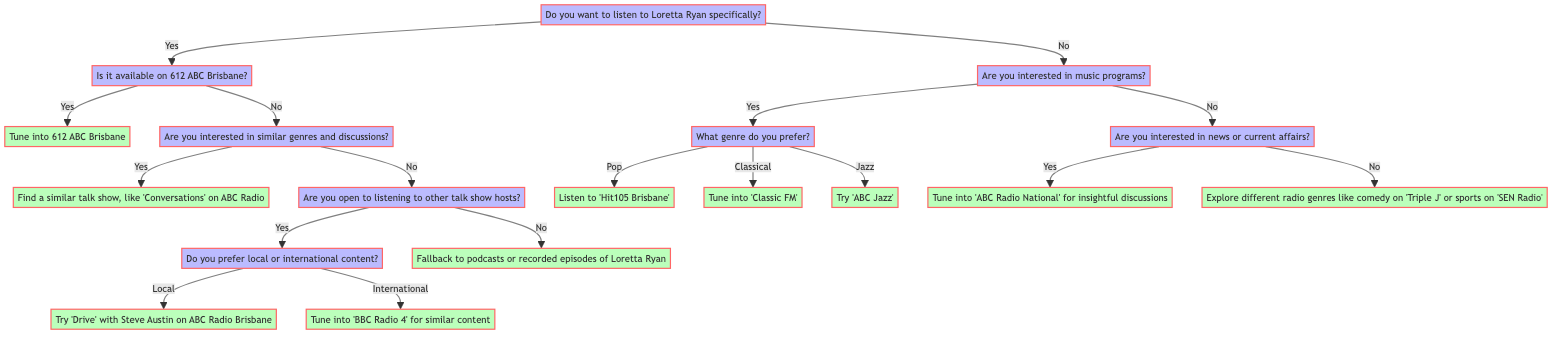What is the starting point of the decision tree? The starting point of the decision tree is the question of whether the listener wants to listen to Loretta Ryan specifically, which is represented as a node labeled "Do you want to listen to Loretta Ryan specifically?"
Answer: Do you want to listen to Loretta Ryan specifically? How many options are there if you want to listen to Loretta Ryan specifically? If the answer is yes to wanting to listen to Loretta Ryan, there are two options available: one for checking if it's available on 612 ABC Brisbane, and another for finding similar genres and discussions if it is not available.
Answer: Two options What is the output if Loretta Ryan is available on 612 ABC Brisbane? If it is available, the next step is to tune into 612 ABC Brisbane, which directly follows the check for availability.
Answer: Tune into 612 ABC Brisbane What should you do if you are not interested in listening to Loretta Ryan? If you are not interested in Loretta Ryan, the next question asked is if you are interested in music programs. If yes, subsequent questions determine the genre; if no, the options shift to news or current affairs or exploring different radio genres.
Answer: Are you interested in music programs? If you are interested in music and prefer Jazz, what will you listen to? The flow of the decision tree indicates that if you choose Jazz as your preferred genre, the output directs you to try 'ABC Jazz', which is the end point of that branch.
Answer: Try 'ABC Jazz' What action should you take if you're open to listening to other talk show hosts but not interested in similar genres? In this scenario, the tree further branches to check if you prefer local or international content. Depending on your preference, you might tune into either 'Drive' with Steve Austin or 'BBC Radio 4', making it a multi-step reasoning process to arrive at the endpoint.
Answer: Depends on local or international preference What happens if you prefer classical music? Choosing classical music leads you directly to the endpoint for that genre, which instructs you to tune into 'Classic FM', following the logic that you had previously confirmed interest in music programs and then specified the genre.
Answer: Tune into 'Classic FM' Are there more than one endpoint for music programs? Yes, the flowchart specifies three unique endpoints for music programs: 'Hit105 Brisbane' for Pop, 'Classic FM' for Classical, and 'ABC Jazz' for Jazz, indicating multiple outcomes depending on genre selection.
Answer: Yes What does the diagram suggest if you're not interested in news or music programs? In this case, if you are not interested in news or current affairs after stating you're not interested in music, the decision tree suggests exploring different radio genres like comedy or sports.
Answer: Explore different radio genres like comedy on 'Triple J' or sports on 'SEN Radio' 